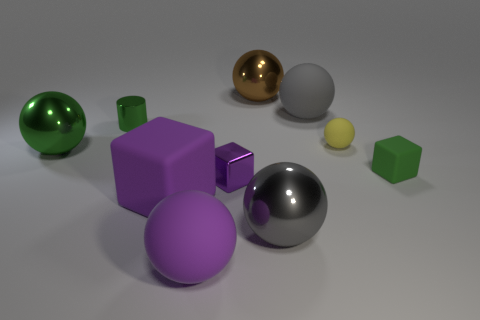There is a gray object that is behind the cube that is to the right of the large gray thing that is in front of the purple shiny object; what is it made of?
Provide a succinct answer. Rubber. There is a matte thing in front of the large purple block; does it have the same shape as the green thing that is behind the green metallic sphere?
Keep it short and to the point. No. Are there any green shiny objects of the same size as the gray shiny sphere?
Your response must be concise. Yes. How many blue things are either shiny cylinders or small matte spheres?
Your response must be concise. 0. What number of big rubber things are the same color as the large cube?
Your response must be concise. 1. Is there any other thing that has the same shape as the small green metal thing?
Your answer should be compact. No. What number of spheres are either big brown objects or purple rubber objects?
Offer a very short reply. 2. There is a large shiny object that is to the left of the big purple ball; what is its color?
Provide a succinct answer. Green. There is a gray matte object that is the same size as the brown thing; what is its shape?
Provide a short and direct response. Sphere. What number of big things are behind the tiny green cube?
Give a very brief answer. 3. 